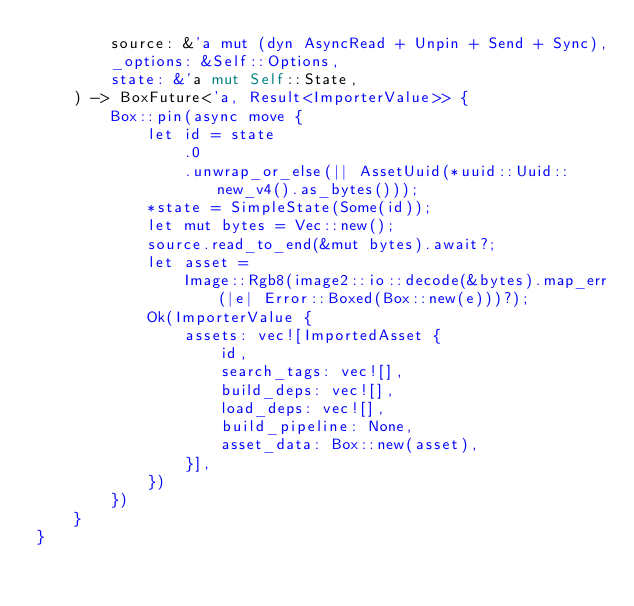Convert code to text. <code><loc_0><loc_0><loc_500><loc_500><_Rust_>        source: &'a mut (dyn AsyncRead + Unpin + Send + Sync),
        _options: &Self::Options,
        state: &'a mut Self::State,
    ) -> BoxFuture<'a, Result<ImporterValue>> {
        Box::pin(async move {
            let id = state
                .0
                .unwrap_or_else(|| AssetUuid(*uuid::Uuid::new_v4().as_bytes()));
            *state = SimpleState(Some(id));
            let mut bytes = Vec::new();
            source.read_to_end(&mut bytes).await?;
            let asset =
                Image::Rgb8(image2::io::decode(&bytes).map_err(|e| Error::Boxed(Box::new(e)))?);
            Ok(ImporterValue {
                assets: vec![ImportedAsset {
                    id,
                    search_tags: vec![],
                    build_deps: vec![],
                    load_deps: vec![],
                    build_pipeline: None,
                    asset_data: Box::new(asset),
                }],
            })
        })
    }
}
</code> 